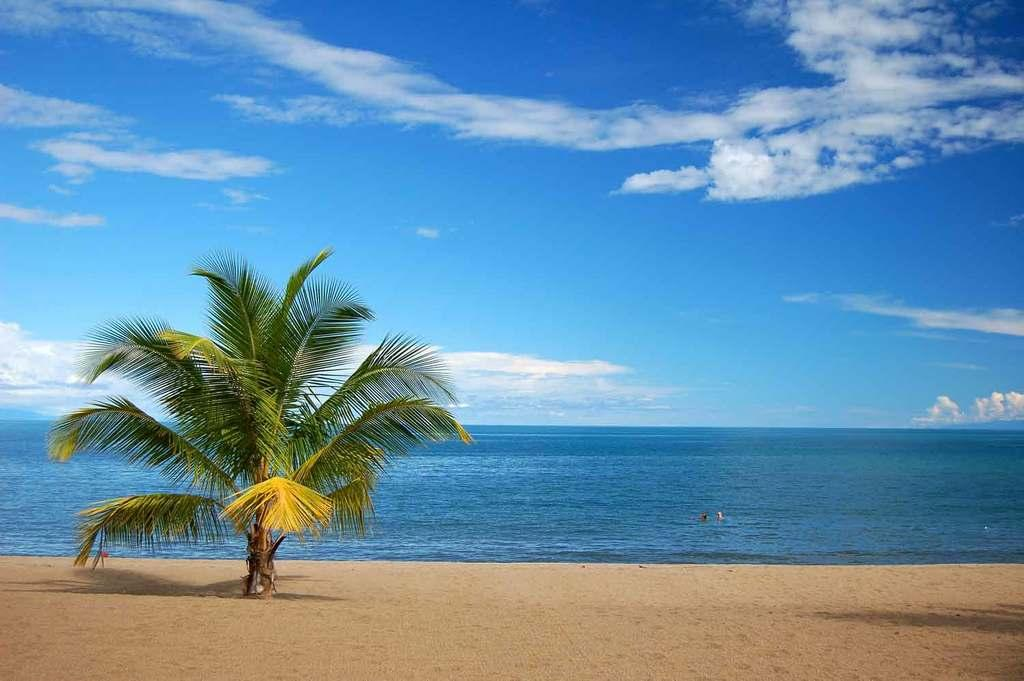What type of tree is on the left side of the image? There is a palm tree on the left side of the image. Where is the palm tree located? The palm tree is on a beach. What can be seen in front of the palm tree? There is an ocean in front of the palm tree. What is visible above the palm tree? The sky is visible above the palm tree. What can be observed in the sky? There are clouds in the sky. Where is the nearest shop to buy a hat in the image? There is no shop present in the image, as it features a palm tree on a beach with an ocean and clouds in the sky. 